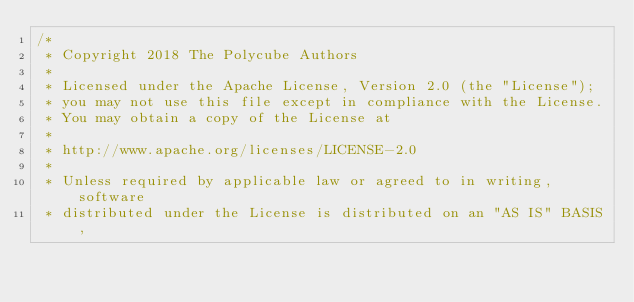Convert code to text. <code><loc_0><loc_0><loc_500><loc_500><_C_>/*
 * Copyright 2018 The Polycube Authors
 *
 * Licensed under the Apache License, Version 2.0 (the "License");
 * you may not use this file except in compliance with the License.
 * You may obtain a copy of the License at
 *
 * http://www.apache.org/licenses/LICENSE-2.0
 *
 * Unless required by applicable law or agreed to in writing, software
 * distributed under the License is distributed on an "AS IS" BASIS,</code> 